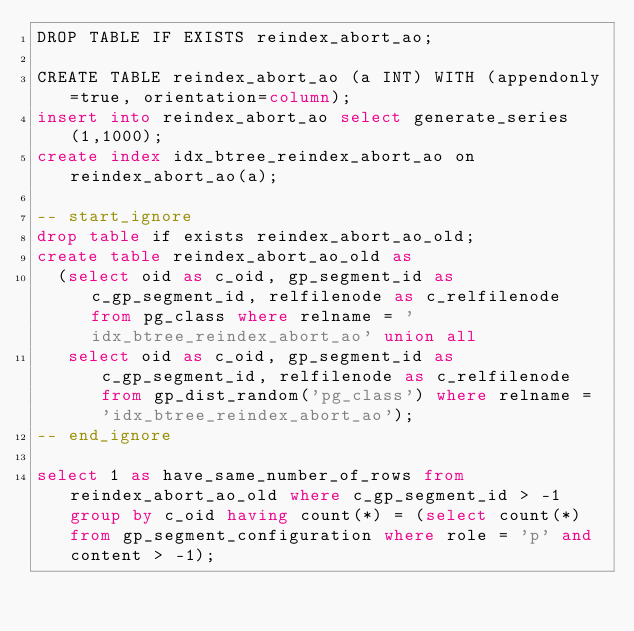<code> <loc_0><loc_0><loc_500><loc_500><_SQL_>DROP TABLE IF EXISTS reindex_abort_ao;

CREATE TABLE reindex_abort_ao (a INT) WITH (appendonly=true, orientation=column);
insert into reindex_abort_ao select generate_series(1,1000);
create index idx_btree_reindex_abort_ao on reindex_abort_ao(a);

-- start_ignore
drop table if exists reindex_abort_ao_old;
create table reindex_abort_ao_old as
  (select oid as c_oid, gp_segment_id as c_gp_segment_id, relfilenode as c_relfilenode from pg_class where relname = 'idx_btree_reindex_abort_ao' union all
   select oid as c_oid, gp_segment_id as c_gp_segment_id, relfilenode as c_relfilenode from gp_dist_random('pg_class') where relname = 'idx_btree_reindex_abort_ao');
-- end_ignore

select 1 as have_same_number_of_rows from reindex_abort_ao_old where c_gp_segment_id > -1 group by c_oid having count(*) = (select count(*) from gp_segment_configuration where role = 'p' and content > -1);
</code> 